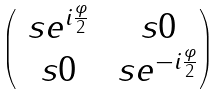Convert formula to latex. <formula><loc_0><loc_0><loc_500><loc_500>\begin{pmatrix} \ s e ^ { i \frac { \varphi } { 2 } } & \ s 0 \\ \ s 0 & \ s e ^ { - i \frac { \varphi } { 2 } } \end{pmatrix}</formula> 